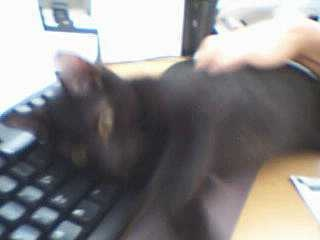Describe the objects in this image and their specific colors. I can see cat in white, gray, black, and darkgray tones, keyboard in white, black, gray, and darkgray tones, and people in white, tan, and darkgray tones in this image. 